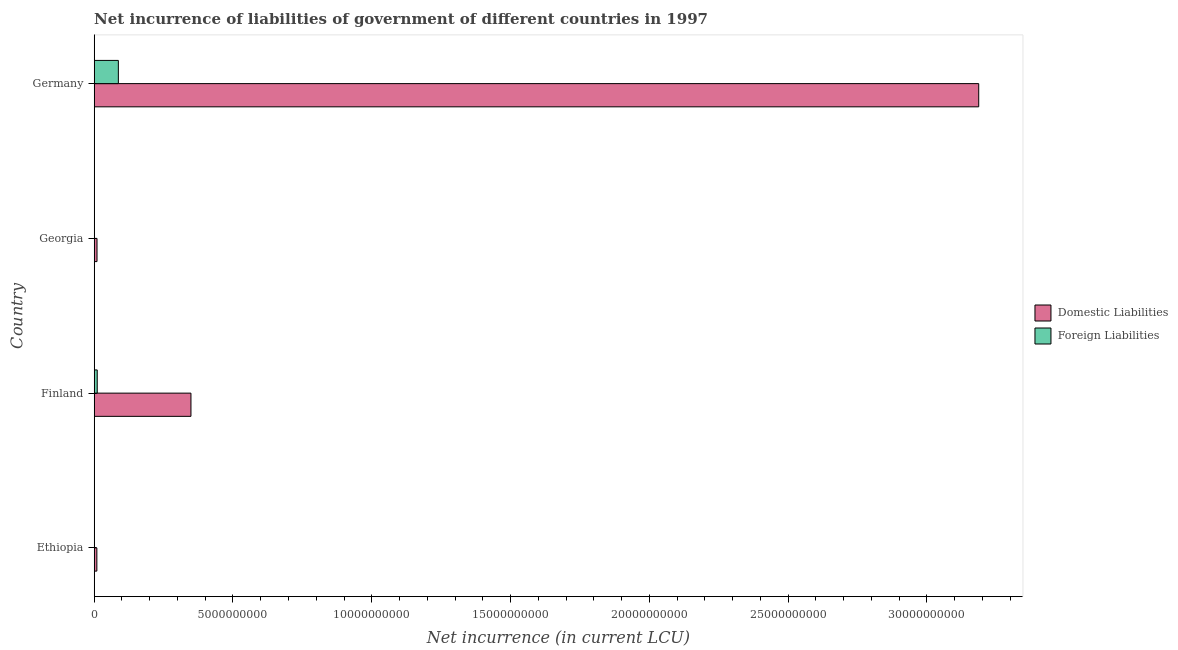How many different coloured bars are there?
Give a very brief answer. 2. Are the number of bars on each tick of the Y-axis equal?
Your response must be concise. No. How many bars are there on the 4th tick from the top?
Your response must be concise. 1. How many bars are there on the 1st tick from the bottom?
Provide a succinct answer. 1. What is the label of the 2nd group of bars from the top?
Your answer should be compact. Georgia. In how many cases, is the number of bars for a given country not equal to the number of legend labels?
Your answer should be compact. 2. What is the net incurrence of foreign liabilities in Finland?
Your answer should be compact. 1.10e+08. Across all countries, what is the maximum net incurrence of domestic liabilities?
Offer a very short reply. 3.19e+1. Across all countries, what is the minimum net incurrence of foreign liabilities?
Make the answer very short. 0. What is the total net incurrence of domestic liabilities in the graph?
Make the answer very short. 3.56e+1. What is the difference between the net incurrence of domestic liabilities in Ethiopia and that in Germany?
Make the answer very short. -3.18e+1. What is the difference between the net incurrence of foreign liabilities in Georgia and the net incurrence of domestic liabilities in Germany?
Provide a short and direct response. -3.19e+1. What is the average net incurrence of foreign liabilities per country?
Give a very brief answer. 2.45e+08. What is the difference between the net incurrence of foreign liabilities and net incurrence of domestic liabilities in Germany?
Make the answer very short. -3.10e+1. What is the ratio of the net incurrence of domestic liabilities in Ethiopia to that in Georgia?
Provide a succinct answer. 0.94. Is the net incurrence of domestic liabilities in Ethiopia less than that in Georgia?
Keep it short and to the point. Yes. What is the difference between the highest and the second highest net incurrence of domestic liabilities?
Make the answer very short. 2.84e+1. What is the difference between the highest and the lowest net incurrence of domestic liabilities?
Your answer should be compact. 3.18e+1. In how many countries, is the net incurrence of foreign liabilities greater than the average net incurrence of foreign liabilities taken over all countries?
Offer a very short reply. 1. Is the sum of the net incurrence of domestic liabilities in Finland and Germany greater than the maximum net incurrence of foreign liabilities across all countries?
Give a very brief answer. Yes. How many bars are there?
Offer a very short reply. 6. Are the values on the major ticks of X-axis written in scientific E-notation?
Your response must be concise. No. Does the graph contain grids?
Offer a terse response. No. How are the legend labels stacked?
Provide a short and direct response. Vertical. What is the title of the graph?
Ensure brevity in your answer.  Net incurrence of liabilities of government of different countries in 1997. Does "External balance on goods" appear as one of the legend labels in the graph?
Offer a terse response. No. What is the label or title of the X-axis?
Ensure brevity in your answer.  Net incurrence (in current LCU). What is the label or title of the Y-axis?
Ensure brevity in your answer.  Country. What is the Net incurrence (in current LCU) in Domestic Liabilities in Ethiopia?
Your response must be concise. 9.56e+07. What is the Net incurrence (in current LCU) in Foreign Liabilities in Ethiopia?
Provide a short and direct response. 0. What is the Net incurrence (in current LCU) in Domestic Liabilities in Finland?
Provide a short and direct response. 3.49e+09. What is the Net incurrence (in current LCU) of Foreign Liabilities in Finland?
Ensure brevity in your answer.  1.10e+08. What is the Net incurrence (in current LCU) of Domestic Liabilities in Georgia?
Provide a succinct answer. 1.01e+08. What is the Net incurrence (in current LCU) in Foreign Liabilities in Georgia?
Offer a very short reply. 0. What is the Net incurrence (in current LCU) in Domestic Liabilities in Germany?
Keep it short and to the point. 3.19e+1. What is the Net incurrence (in current LCU) in Foreign Liabilities in Germany?
Provide a succinct answer. 8.71e+08. Across all countries, what is the maximum Net incurrence (in current LCU) of Domestic Liabilities?
Make the answer very short. 3.19e+1. Across all countries, what is the maximum Net incurrence (in current LCU) of Foreign Liabilities?
Offer a very short reply. 8.71e+08. Across all countries, what is the minimum Net incurrence (in current LCU) of Domestic Liabilities?
Your answer should be very brief. 9.56e+07. What is the total Net incurrence (in current LCU) in Domestic Liabilities in the graph?
Offer a very short reply. 3.56e+1. What is the total Net incurrence (in current LCU) of Foreign Liabilities in the graph?
Offer a very short reply. 9.80e+08. What is the difference between the Net incurrence (in current LCU) of Domestic Liabilities in Ethiopia and that in Finland?
Provide a succinct answer. -3.39e+09. What is the difference between the Net incurrence (in current LCU) of Domestic Liabilities in Ethiopia and that in Georgia?
Your answer should be compact. -5.70e+06. What is the difference between the Net incurrence (in current LCU) of Domestic Liabilities in Ethiopia and that in Germany?
Make the answer very short. -3.18e+1. What is the difference between the Net incurrence (in current LCU) of Domestic Liabilities in Finland and that in Georgia?
Your answer should be very brief. 3.38e+09. What is the difference between the Net incurrence (in current LCU) in Domestic Liabilities in Finland and that in Germany?
Your answer should be compact. -2.84e+1. What is the difference between the Net incurrence (in current LCU) in Foreign Liabilities in Finland and that in Germany?
Your answer should be very brief. -7.61e+08. What is the difference between the Net incurrence (in current LCU) of Domestic Liabilities in Georgia and that in Germany?
Provide a succinct answer. -3.18e+1. What is the difference between the Net incurrence (in current LCU) of Domestic Liabilities in Ethiopia and the Net incurrence (in current LCU) of Foreign Liabilities in Finland?
Your answer should be very brief. -1.39e+07. What is the difference between the Net incurrence (in current LCU) in Domestic Liabilities in Ethiopia and the Net incurrence (in current LCU) in Foreign Liabilities in Germany?
Your response must be concise. -7.75e+08. What is the difference between the Net incurrence (in current LCU) in Domestic Liabilities in Finland and the Net incurrence (in current LCU) in Foreign Liabilities in Germany?
Make the answer very short. 2.62e+09. What is the difference between the Net incurrence (in current LCU) in Domestic Liabilities in Georgia and the Net incurrence (in current LCU) in Foreign Liabilities in Germany?
Offer a very short reply. -7.69e+08. What is the average Net incurrence (in current LCU) of Domestic Liabilities per country?
Provide a succinct answer. 8.89e+09. What is the average Net incurrence (in current LCU) in Foreign Liabilities per country?
Provide a succinct answer. 2.45e+08. What is the difference between the Net incurrence (in current LCU) of Domestic Liabilities and Net incurrence (in current LCU) of Foreign Liabilities in Finland?
Provide a short and direct response. 3.38e+09. What is the difference between the Net incurrence (in current LCU) of Domestic Liabilities and Net incurrence (in current LCU) of Foreign Liabilities in Germany?
Your answer should be very brief. 3.10e+1. What is the ratio of the Net incurrence (in current LCU) of Domestic Liabilities in Ethiopia to that in Finland?
Keep it short and to the point. 0.03. What is the ratio of the Net incurrence (in current LCU) in Domestic Liabilities in Ethiopia to that in Georgia?
Keep it short and to the point. 0.94. What is the ratio of the Net incurrence (in current LCU) in Domestic Liabilities in Ethiopia to that in Germany?
Your response must be concise. 0. What is the ratio of the Net incurrence (in current LCU) in Domestic Liabilities in Finland to that in Georgia?
Provide a succinct answer. 34.41. What is the ratio of the Net incurrence (in current LCU) of Domestic Liabilities in Finland to that in Germany?
Your response must be concise. 0.11. What is the ratio of the Net incurrence (in current LCU) in Foreign Liabilities in Finland to that in Germany?
Your answer should be compact. 0.13. What is the ratio of the Net incurrence (in current LCU) of Domestic Liabilities in Georgia to that in Germany?
Provide a succinct answer. 0. What is the difference between the highest and the second highest Net incurrence (in current LCU) in Domestic Liabilities?
Make the answer very short. 2.84e+1. What is the difference between the highest and the lowest Net incurrence (in current LCU) in Domestic Liabilities?
Your answer should be compact. 3.18e+1. What is the difference between the highest and the lowest Net incurrence (in current LCU) of Foreign Liabilities?
Provide a short and direct response. 8.71e+08. 